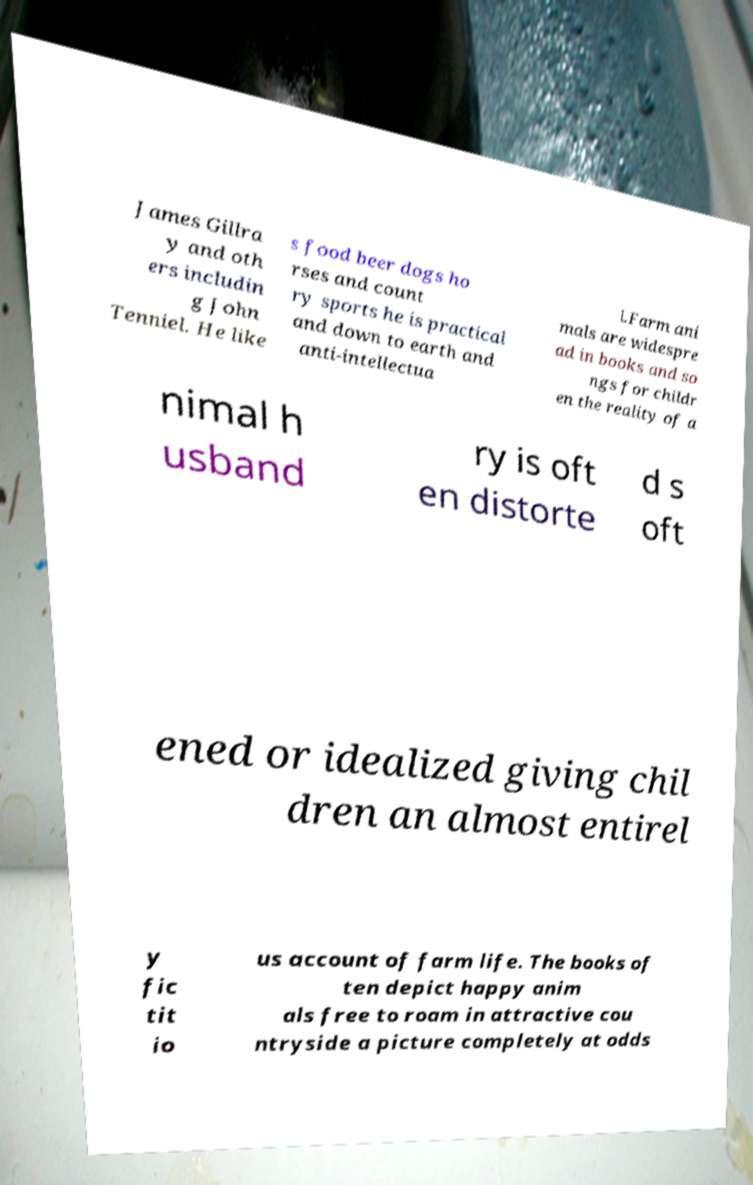There's text embedded in this image that I need extracted. Can you transcribe it verbatim? James Gillra y and oth ers includin g John Tenniel. He like s food beer dogs ho rses and count ry sports he is practical and down to earth and anti-intellectua l.Farm ani mals are widespre ad in books and so ngs for childr en the reality of a nimal h usband ry is oft en distorte d s oft ened or idealized giving chil dren an almost entirel y fic tit io us account of farm life. The books of ten depict happy anim als free to roam in attractive cou ntryside a picture completely at odds 